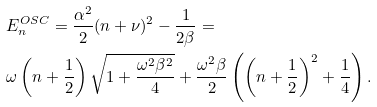Convert formula to latex. <formula><loc_0><loc_0><loc_500><loc_500>& E ^ { O S C } _ { n } = \frac { \alpha ^ { 2 } } { 2 } ( n + \nu ) ^ { 2 } - \frac { 1 } { 2 \beta } = \\ & \omega \left ( n + \frac { 1 } { 2 } \right ) \sqrt { 1 + \frac { \omega ^ { 2 } \beta ^ { 2 } } { 4 } } + \frac { \omega ^ { 2 } \beta } { 2 } \left ( \left ( n + \frac { 1 } { 2 } \right ) ^ { 2 } + \frac { 1 } { 4 } \right ) .</formula> 